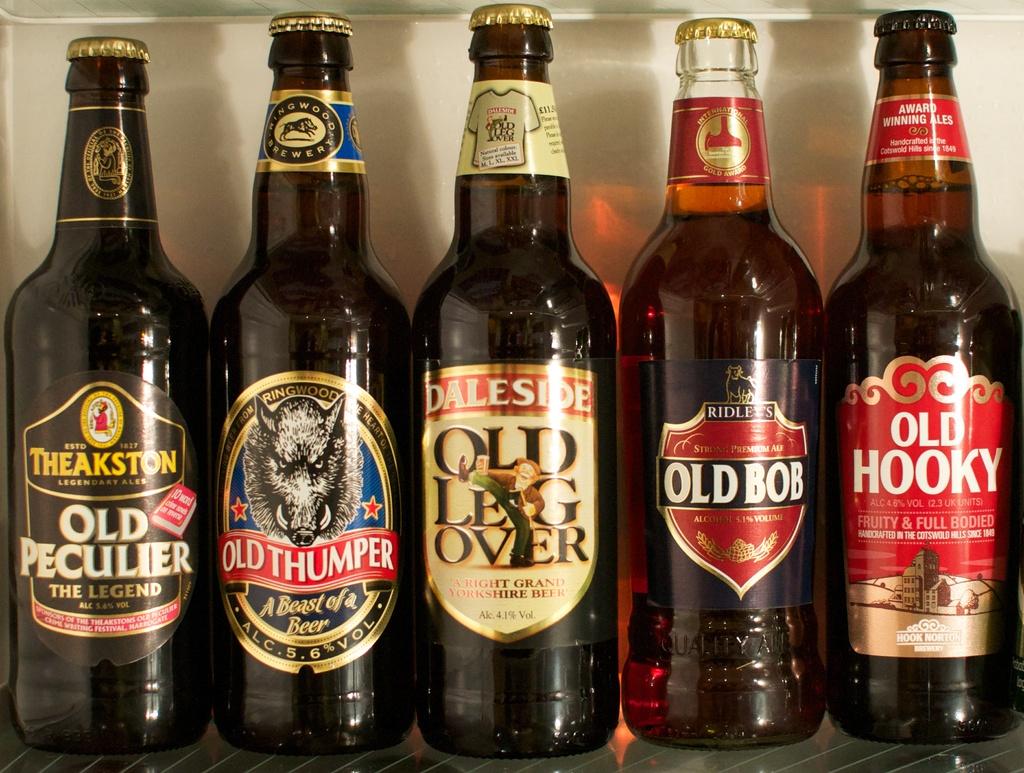What are the beers?
Your response must be concise. Old. What is the name of the 2nd beer?
Make the answer very short. Old thumper. 